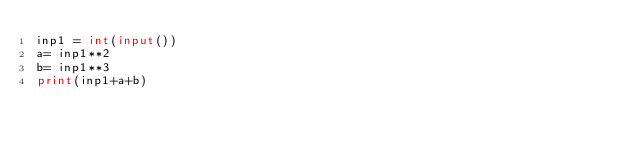Convert code to text. <code><loc_0><loc_0><loc_500><loc_500><_Python_>inp1 = int(input())
a= inp1**2
b= inp1**3
print(inp1+a+b)</code> 